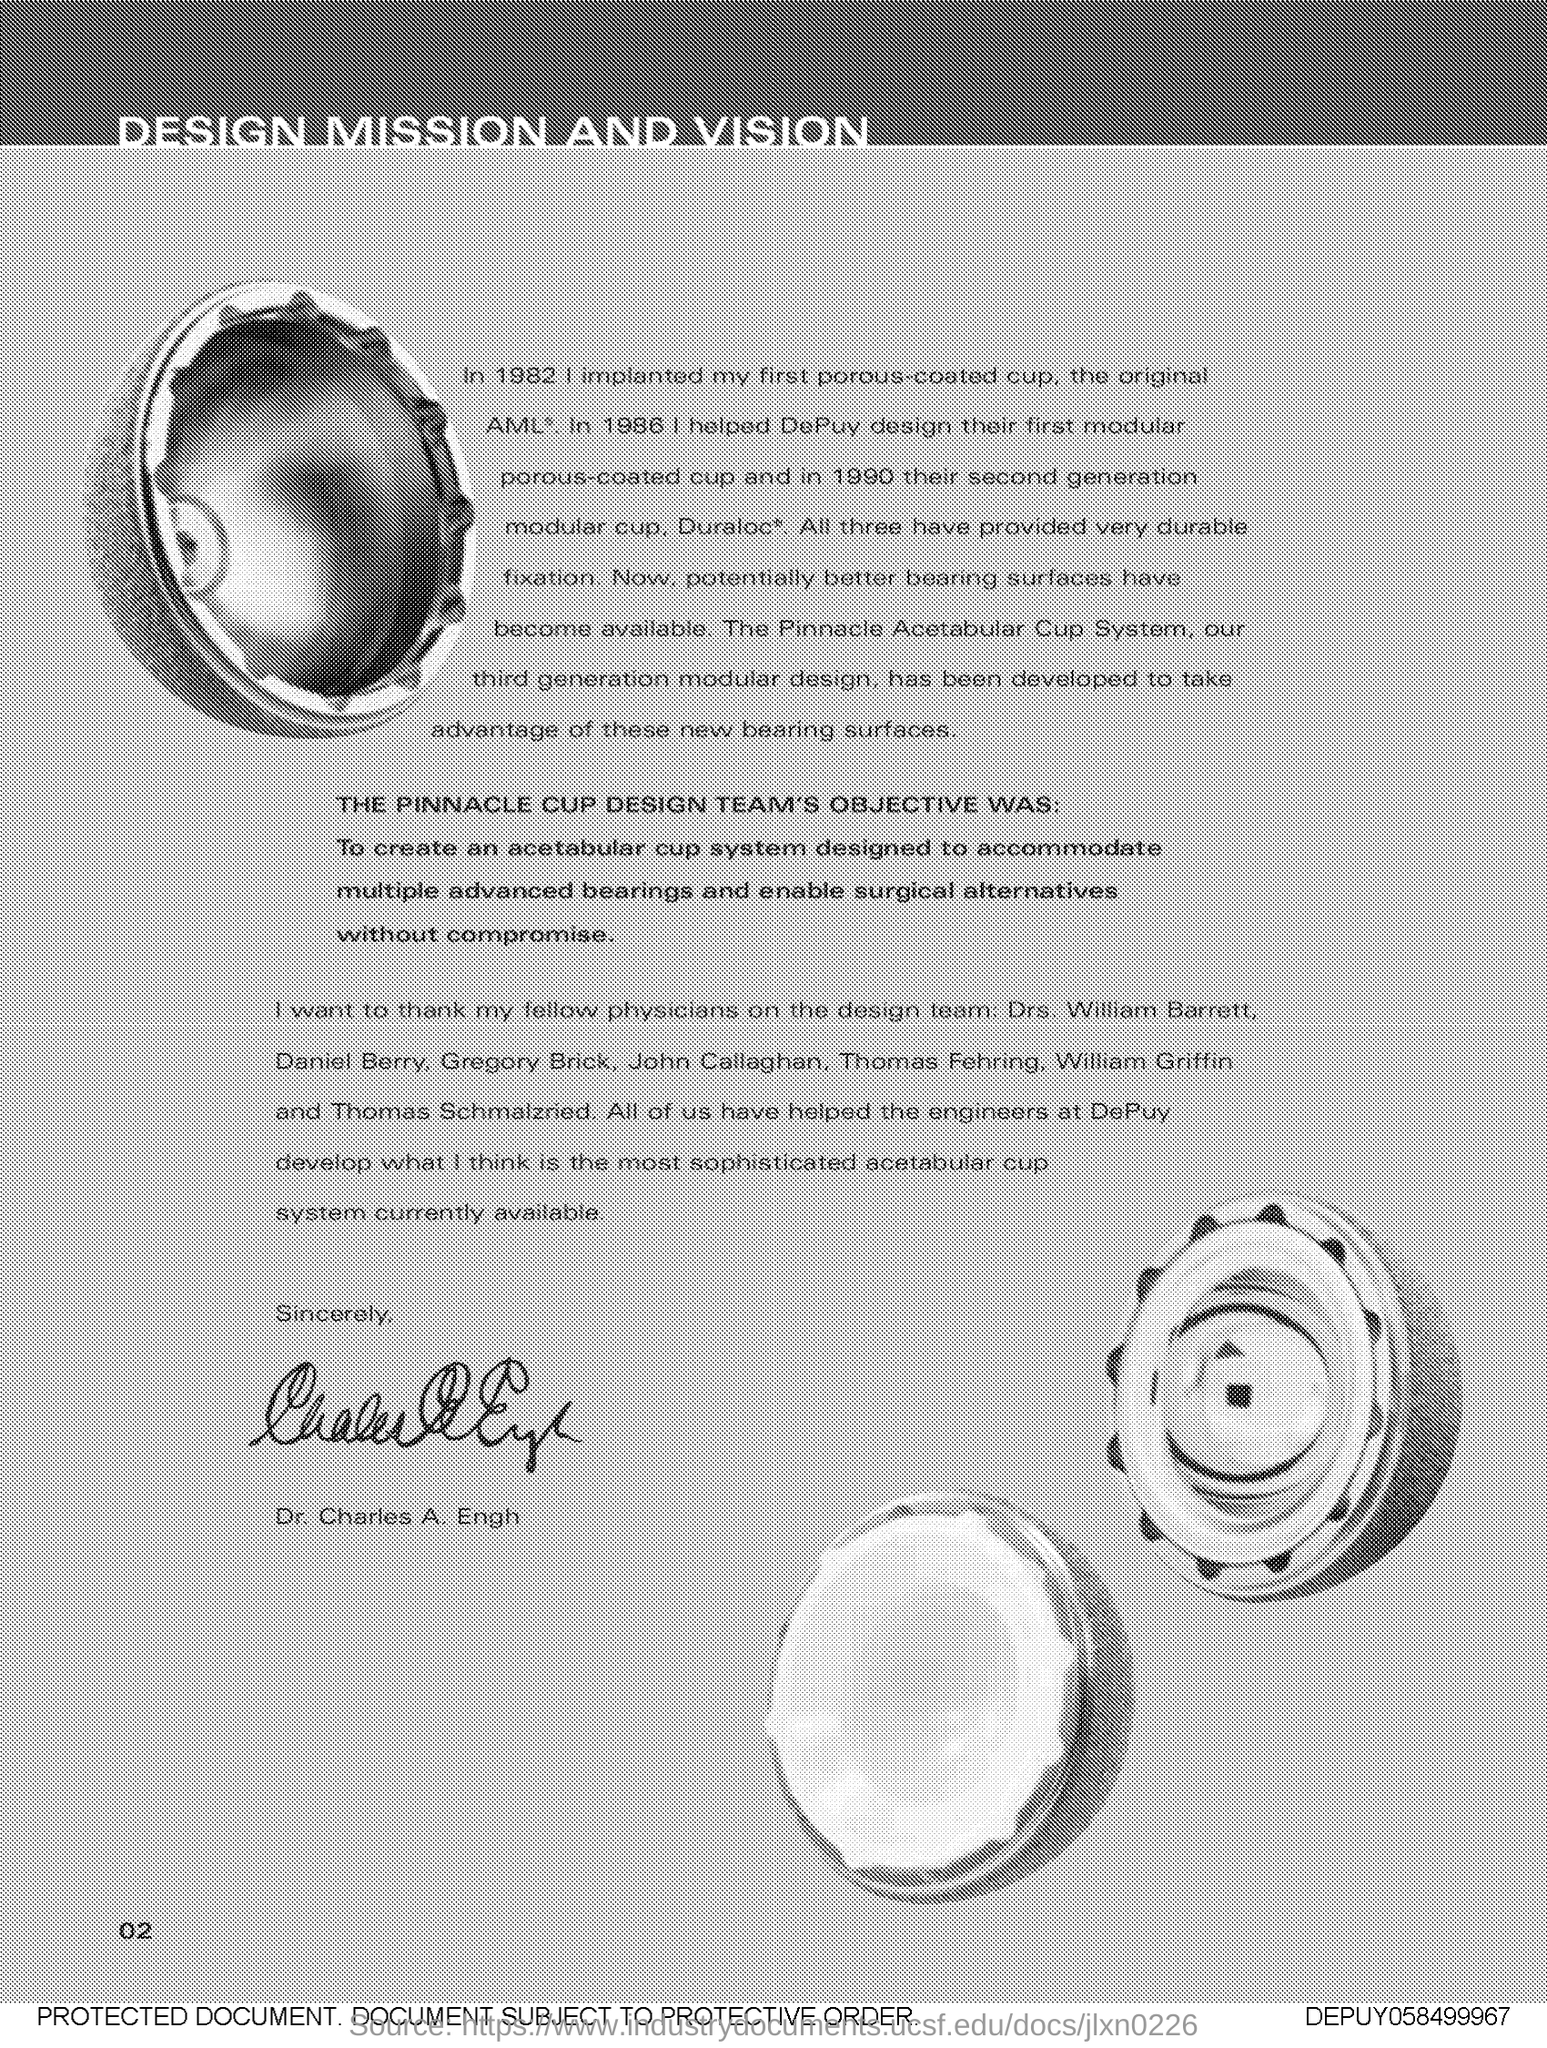Outline some significant characteristics in this image. The number at the bottom left side of the page is 02. 